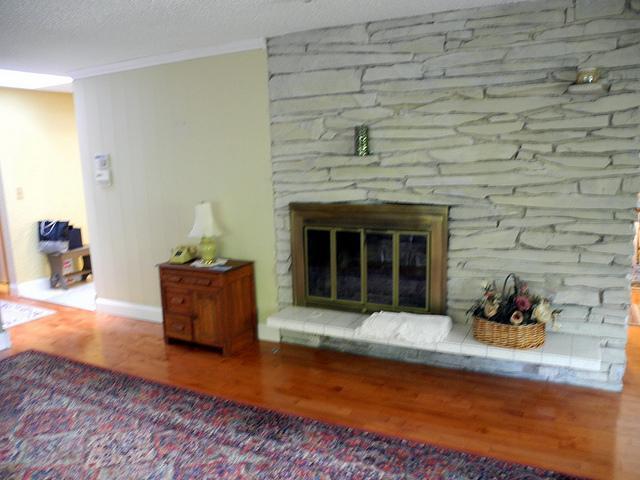How many cars in the left lane?
Give a very brief answer. 0. 